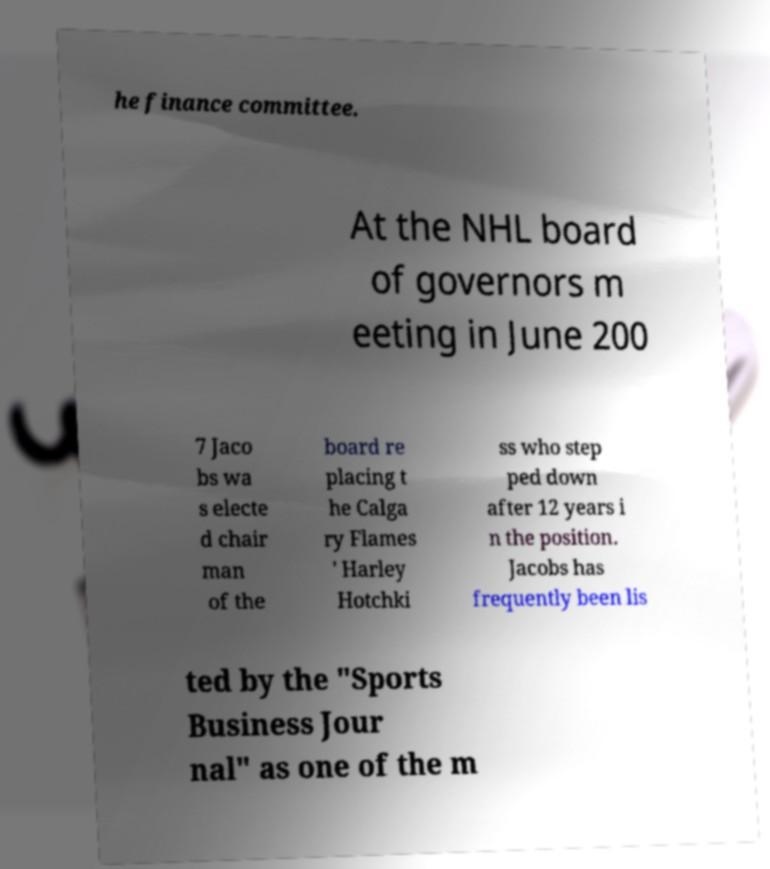There's text embedded in this image that I need extracted. Can you transcribe it verbatim? he finance committee. At the NHL board of governors m eeting in June 200 7 Jaco bs wa s electe d chair man of the board re placing t he Calga ry Flames ' Harley Hotchki ss who step ped down after 12 years i n the position. Jacobs has frequently been lis ted by the "Sports Business Jour nal" as one of the m 